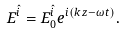<formula> <loc_0><loc_0><loc_500><loc_500>E ^ { \hat { i } } = E _ { 0 } ^ { \hat { i } } e ^ { i ( k z - \omega t ) } .</formula> 